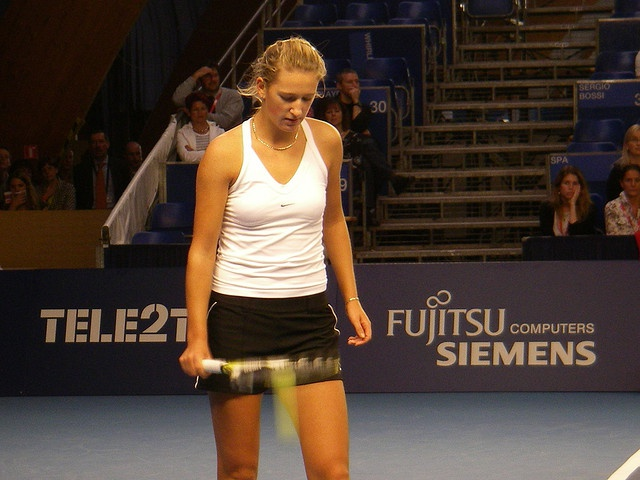Describe the objects in this image and their specific colors. I can see people in black, ivory, brown, and orange tones, tennis racket in black, olive, maroon, and tan tones, people in black, maroon, and gray tones, people in black, maroon, and gray tones, and people in black, maroon, and brown tones in this image. 